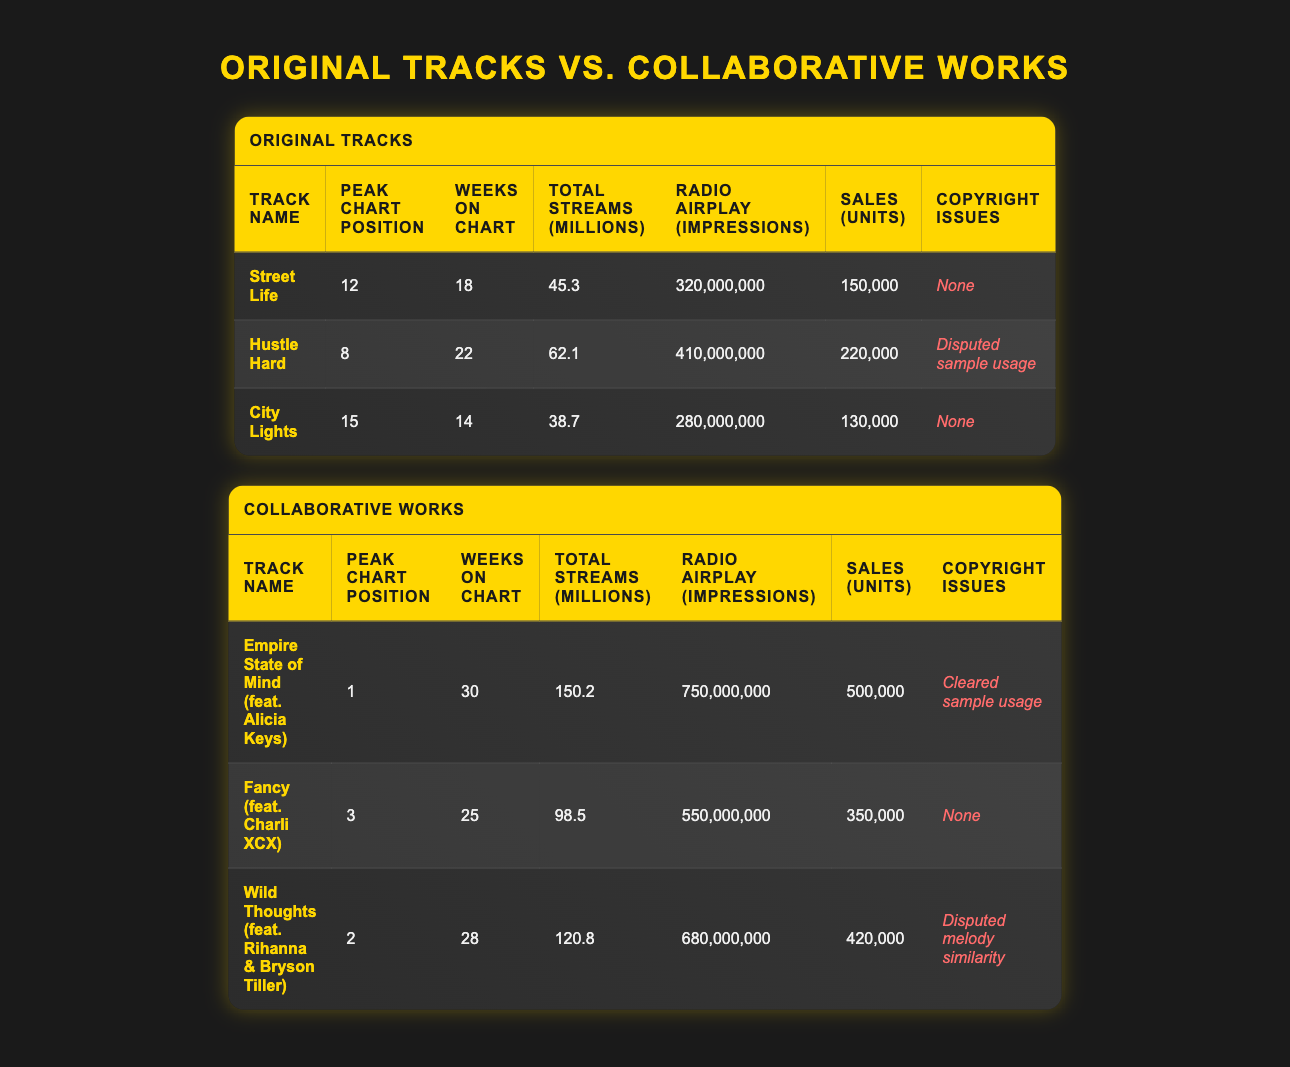What is the peak chart position of "Hustle Hard"? The peak chart position of "Hustle Hard" is listed directly in the table under the "Peak Chart Position" column for that track.
Answer: 8 Which track has the highest total streams? By comparing the "Total Streams (millions)" column across all tracks, "Empire State of Mind (feat. Alicia Keys)" has the highest total streams of 150.2 million.
Answer: Empire State of Mind (feat. Alicia Keys) How many weeks did "Fancy (feat. Charli XCX)" spend on the chart? The number of weeks "Fancy (feat. Charli XCX)" spent on the chart is provided in the "Weeks on Chart" column, which indicates it spent 25 weeks on the chart.
Answer: 25 What is the total number of sales for all original tracks combined? To find the total sales for all original tracks, I sum the sales of each track: 150000 + 220000 + 130000 = 500000 units.
Answer: 500000 Do any tracks have copyright issues? Yes, by reviewing the "Copyright Issues" column, it is clear that both "Hustle Hard" and "Wild Thoughts (feat. Rihanna & Bryson Tiller)" have reported copyright issues.
Answer: Yes Which collaborative track spent the most weeks on the chart? "Empire State of Mind (feat. Alicia Keys)" spent the most weeks on the chart, as indicated by the "Weeks on Chart" column, where it shows 30 weeks, the highest among all tracks.
Answer: Empire State of Mind (feat. Alicia Keys) What is the average total streams for collaborative works? First, I add up the total streams of the collaborative tracks: 150.2 + 98.5 + 120.8 = 369.5 million. Then, I divide by the number of collaborative tracks (3): 369.5 / 3 = 123.17 million.
Answer: 123.17 million Which original track had a clearer copyright issue? By checking the "Copyright Issues" for all original tracks, "Hustle Hard" has the conflicted "Disputed sample usage," while others like "Street Life" and "City Lights" have none. Thus, "Hustle Hard" represents a clearer dispute.
Answer: Hustle Hard Are there more collaborative tracks or original tracks? There are 3 original tracks and 3 collaborative works according to the table, which makes them equal in number.
Answer: Equal 